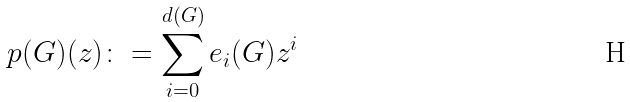Convert formula to latex. <formula><loc_0><loc_0><loc_500><loc_500>p ( G ) ( z ) \colon = \sum _ { i = 0 } ^ { d ( G ) } e _ { i } ( G ) z ^ { i }</formula> 